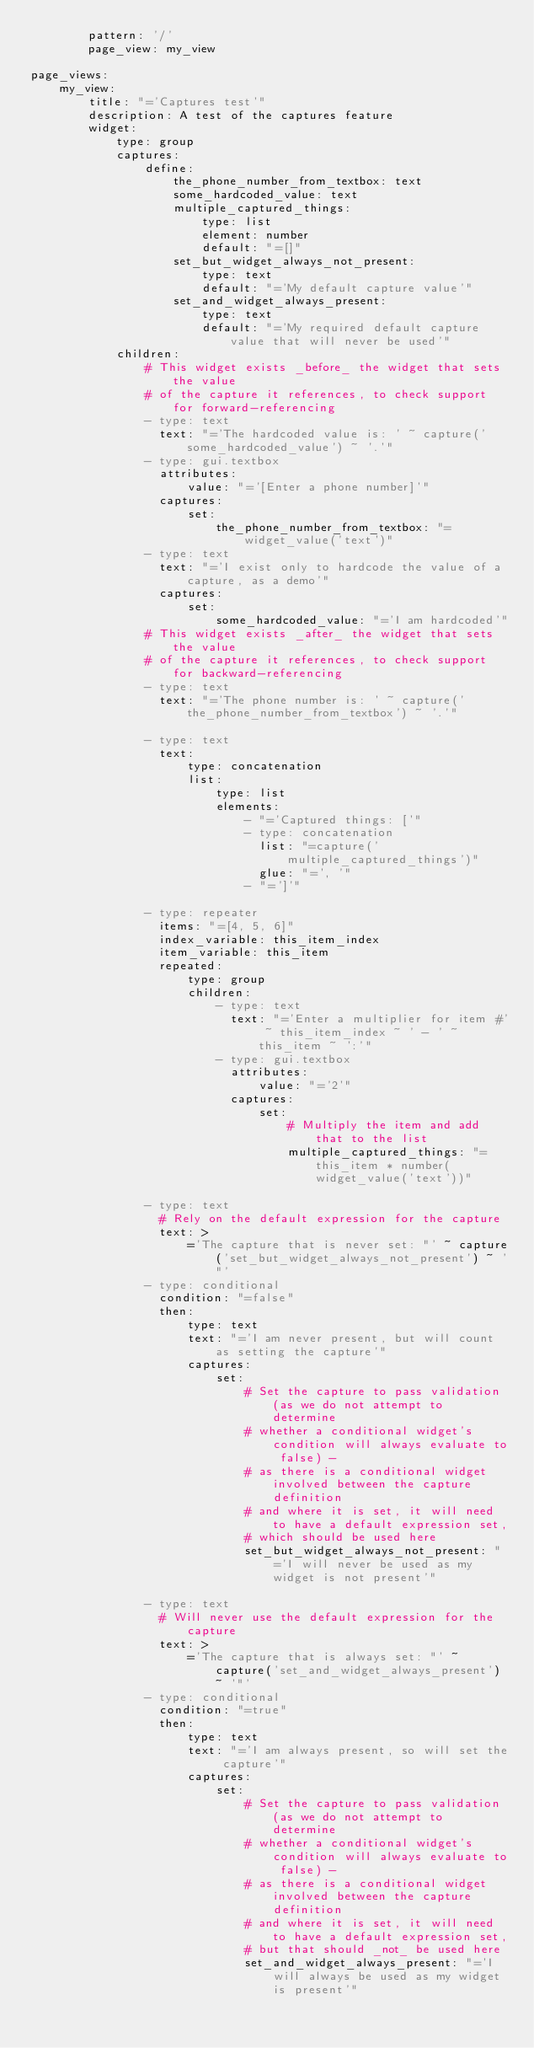Convert code to text. <code><loc_0><loc_0><loc_500><loc_500><_YAML_>        pattern: '/'
        page_view: my_view

page_views:
    my_view:
        title: "='Captures test'"
        description: A test of the captures feature
        widget:
            type: group
            captures:
                define:
                    the_phone_number_from_textbox: text
                    some_hardcoded_value: text
                    multiple_captured_things:
                        type: list
                        element: number
                        default: "=[]"
                    set_but_widget_always_not_present:
                        type: text
                        default: "='My default capture value'"
                    set_and_widget_always_present:
                        type: text
                        default: "='My required default capture value that will never be used'"
            children:
                # This widget exists _before_ the widget that sets the value
                # of the capture it references, to check support for forward-referencing
                - type: text
                  text: "='The hardcoded value is: ' ~ capture('some_hardcoded_value') ~ '.'"
                - type: gui.textbox
                  attributes:
                      value: "='[Enter a phone number]'"
                  captures:
                      set:
                          the_phone_number_from_textbox: "=widget_value('text')"
                - type: text
                  text: "='I exist only to hardcode the value of a capture, as a demo'"
                  captures:
                      set:
                          some_hardcoded_value: "='I am hardcoded'"
                # This widget exists _after_ the widget that sets the value
                # of the capture it references, to check support for backward-referencing
                - type: text
                  text: "='The phone number is: ' ~ capture('the_phone_number_from_textbox') ~ '.'"

                - type: text
                  text:
                      type: concatenation
                      list:
                          type: list
                          elements:
                              - "='Captured things: ['"
                              - type: concatenation
                                list: "=capture('multiple_captured_things')"
                                glue: "=', '"
                              - "=']'"

                - type: repeater
                  items: "=[4, 5, 6]"
                  index_variable: this_item_index
                  item_variable: this_item
                  repeated:
                      type: group
                      children:
                          - type: text
                            text: "='Enter a multiplier for item #' ~ this_item_index ~ ' - ' ~ this_item ~ ':'"
                          - type: gui.textbox
                            attributes:
                                value: "='2'"
                            captures:
                                set:
                                    # Multiply the item and add that to the list
                                    multiple_captured_things: "=this_item * number(widget_value('text'))"

                - type: text
                  # Rely on the default expression for the capture
                  text: >
                      ='The capture that is never set: "' ~ capture('set_but_widget_always_not_present') ~ '"'
                - type: conditional
                  condition: "=false"
                  then:
                      type: text
                      text: "='I am never present, but will count as setting the capture'"
                      captures:
                          set:
                              # Set the capture to pass validation (as we do not attempt to determine
                              # whether a conditional widget's condition will always evaluate to false) -
                              # as there is a conditional widget involved between the capture definition
                              # and where it is set, it will need to have a default expression set,
                              # which should be used here
                              set_but_widget_always_not_present: "='I will never be used as my widget is not present'"

                - type: text
                  # Will never use the default expression for the capture
                  text: >
                      ='The capture that is always set: "' ~ capture('set_and_widget_always_present') ~ '"'
                - type: conditional
                  condition: "=true"
                  then:
                      type: text
                      text: "='I am always present, so will set the capture'"
                      captures:
                          set:
                              # Set the capture to pass validation (as we do not attempt to determine
                              # whether a conditional widget's condition will always evaluate to false) -
                              # as there is a conditional widget involved between the capture definition
                              # and where it is set, it will need to have a default expression set,
                              # but that should _not_ be used here
                              set_and_widget_always_present: "='I will always be used as my widget is present'"
</code> 